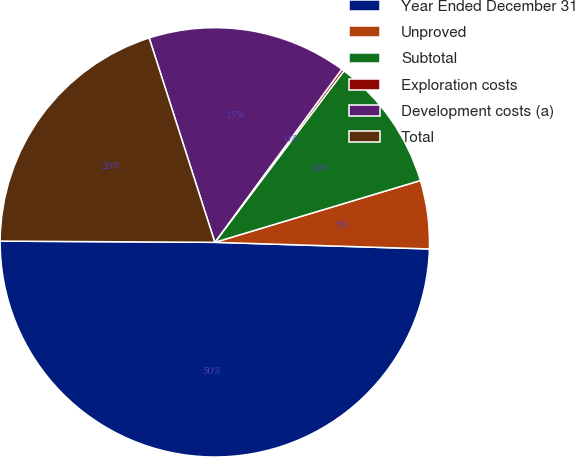<chart> <loc_0><loc_0><loc_500><loc_500><pie_chart><fcel>Year Ended December 31<fcel>Unproved<fcel>Subtotal<fcel>Exploration costs<fcel>Development costs (a)<fcel>Total<nl><fcel>49.6%<fcel>5.14%<fcel>10.08%<fcel>0.2%<fcel>15.02%<fcel>19.96%<nl></chart> 